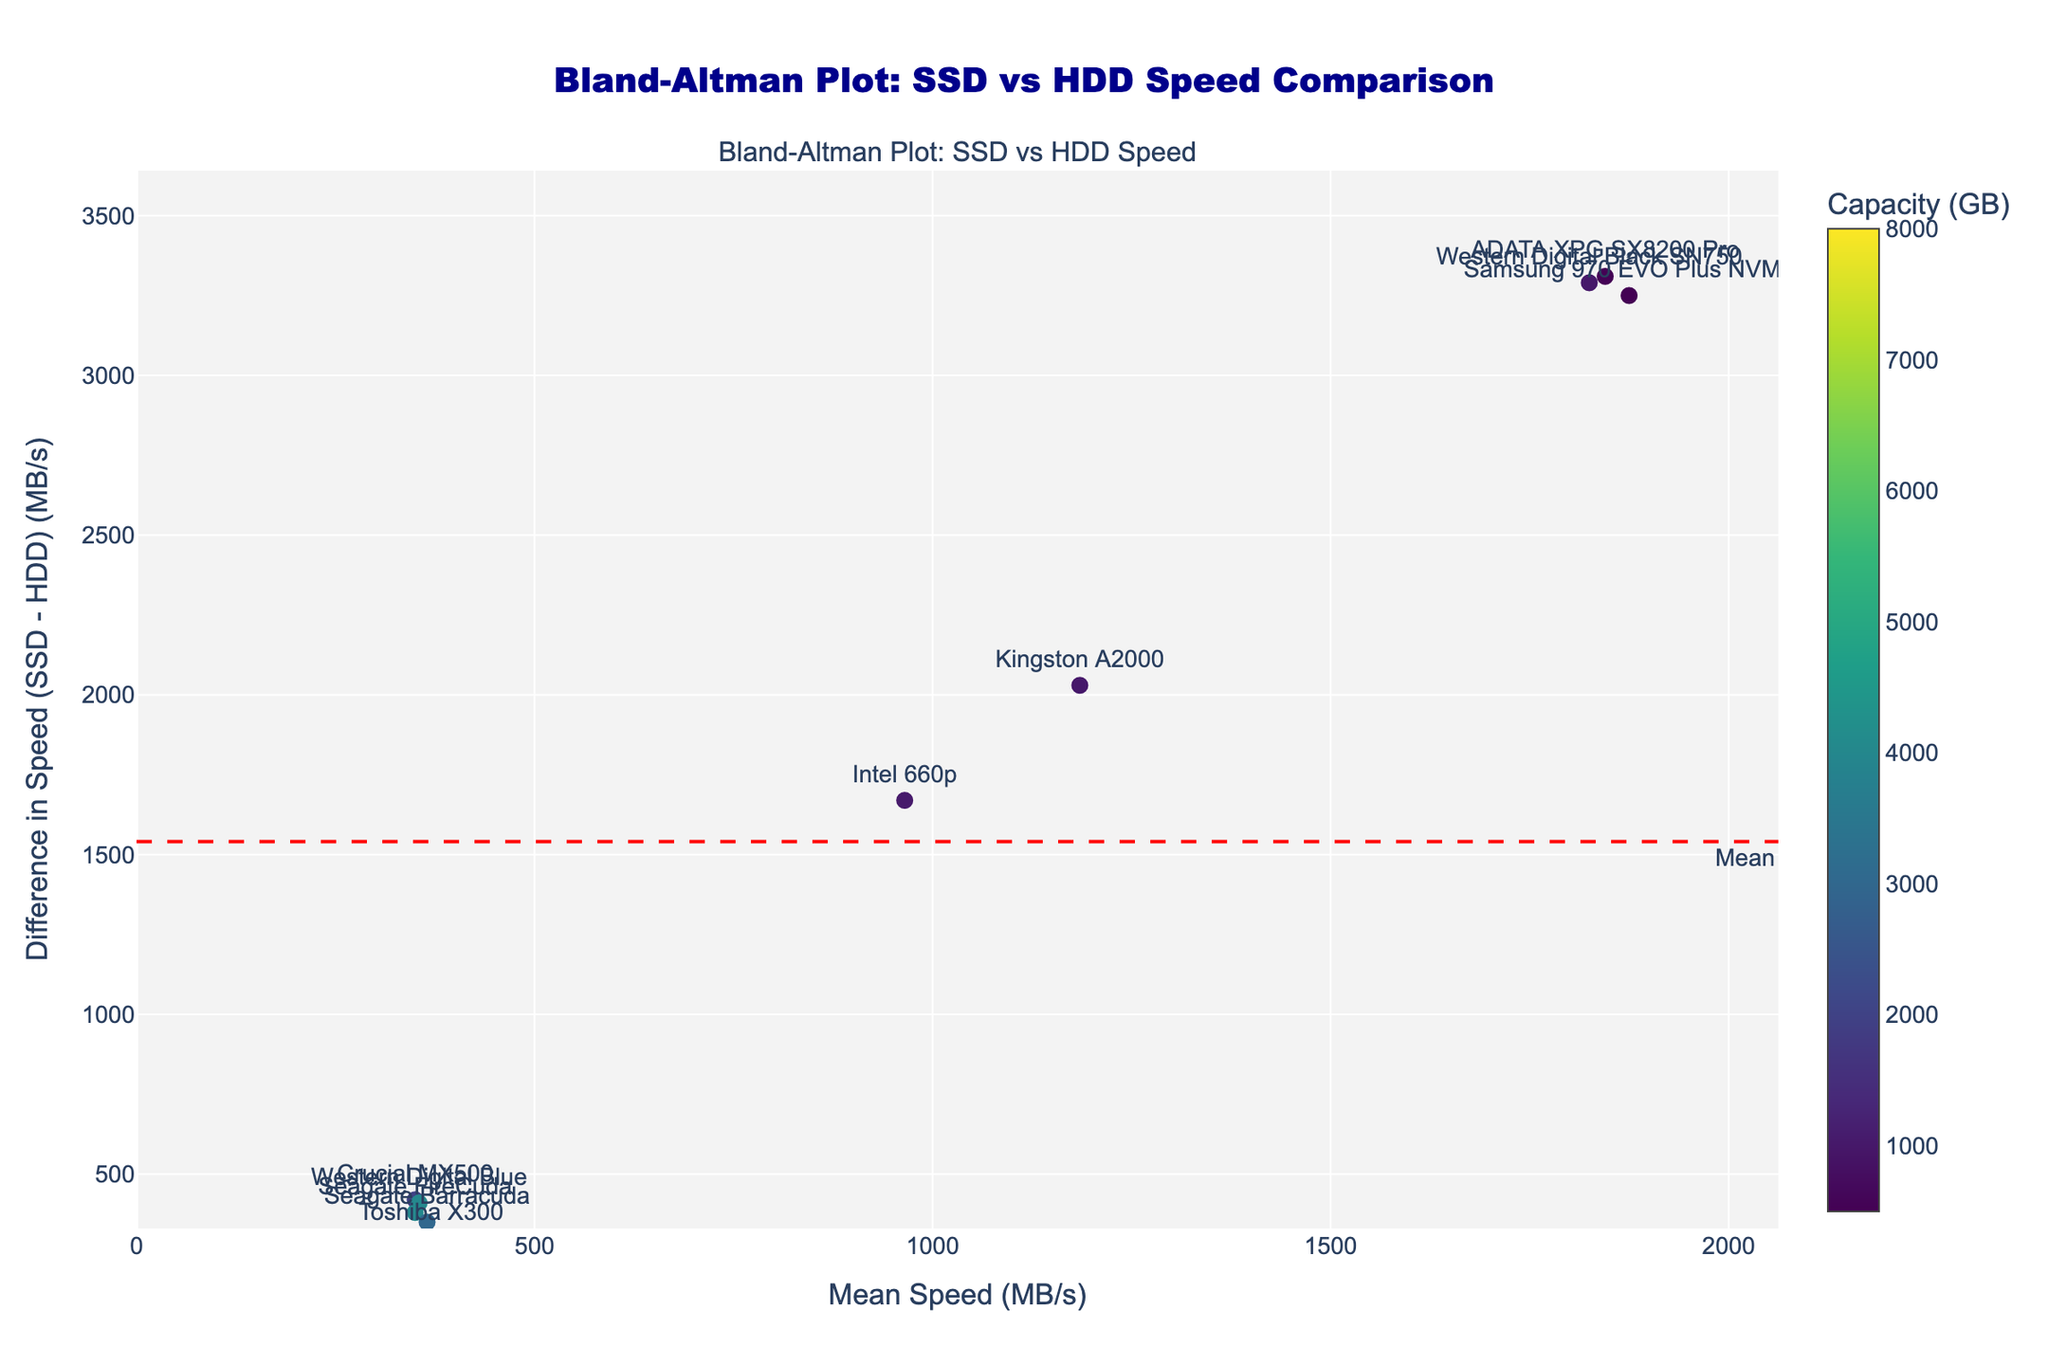What is the title of the figure? The title is usually located at the top of the figure and provides a summary of the plot
Answer: Bland-Altman Plot: SSD vs HDD Speed Comparison How many data points are in the plot? Count the number of markers shown in the scatter plot
Answer: 10 What are the x-axis and y-axis labels? Look for the labels along the axes
Answer: x-axis: Mean Speed (MB/s), y-axis: Difference in Speed (SSD - HDD) (MB/s) What do the colors of the markers represent? Notice the color legend or color bar on the plot
Answer: Capacity (GB) Which data point has the highest SSD speed? Identify the point furthest to the right, check its hover info
Answer: Samsung 970 EVO Plus NVMe What is the mean difference in speed between SSDs and HDDs? Locate the dashed horizontal line and its annotation for the mean difference
Answer: Mean: 2150 MB/s (approx.) What are the upper and lower limits of agreement for the speed difference? Locate the dotted horizontal lines labeled as +1.96 SD and -1.96 SD
Answer: +1.96 SD: ~2850 MB/s, -1.96 SD: ~1450 MB/s What is the data retrieval speed difference for the Toshiba X300? Find the Toshiba X300 marker and read the y-coordinate
Answer: 300 MB/s Is the speed difference for the Intel 660p above or below the mean difference? Locate Intel 660p on the plot and see if it is above or below the mean difference line
Answer: Below Which drive has the closest data retrieval speed to the mean speed? Check the points near the mean speed value on the x-axis
Answer: Western Digital Black SN750 